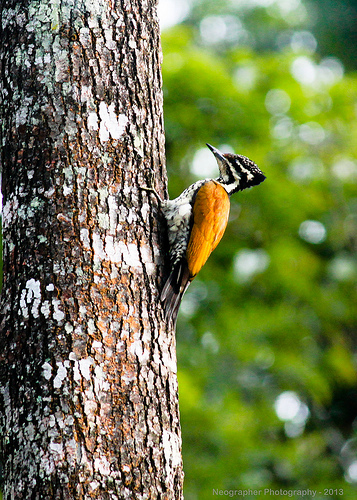Please provide the bounding box coordinate of the region this sentence describes: white spot on tree bark. The specified coordinates [0.22, 0.72, 0.25, 0.76] effectively isolate a distinct white spot on the tree bark, possibly resulting from fungal growth or environmental wear. 